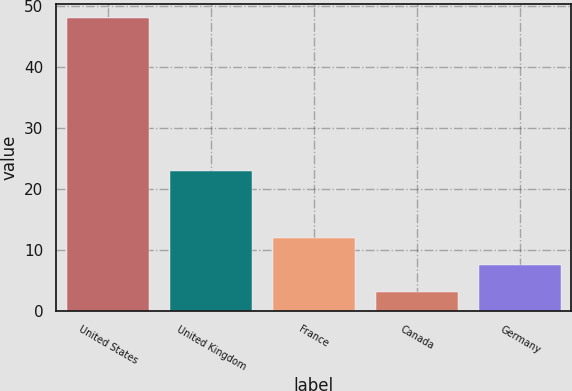Convert chart to OTSL. <chart><loc_0><loc_0><loc_500><loc_500><bar_chart><fcel>United States<fcel>United Kingdom<fcel>France<fcel>Canada<fcel>Germany<nl><fcel>48<fcel>23<fcel>12<fcel>3<fcel>7.5<nl></chart> 